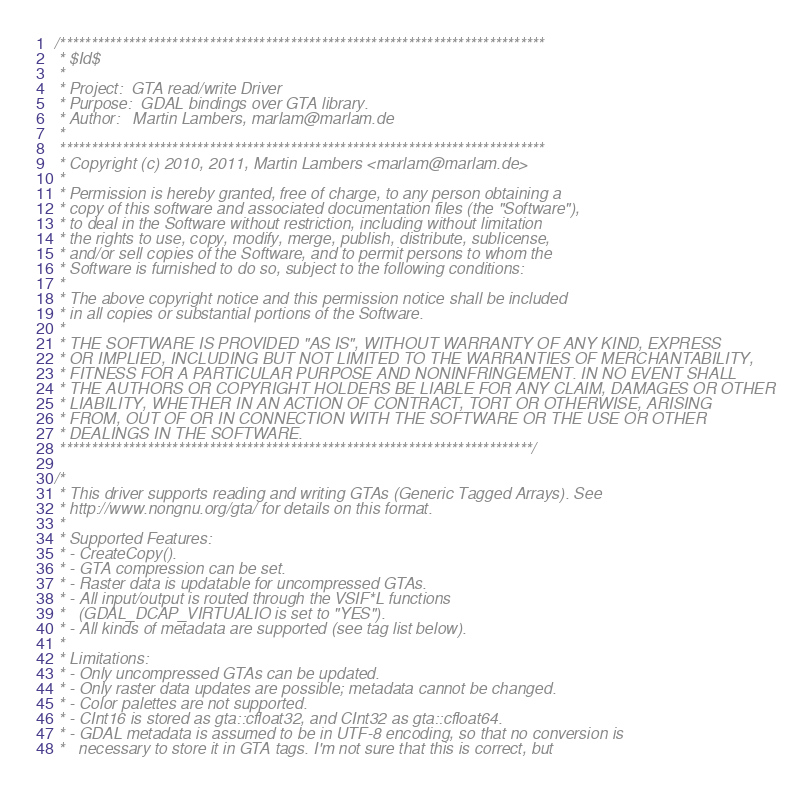<code> <loc_0><loc_0><loc_500><loc_500><_C++_>/******************************************************************************
 * $Id$
 *
 * Project:  GTA read/write Driver
 * Purpose:  GDAL bindings over GTA library.
 * Author:   Martin Lambers, marlam@marlam.de
 *
 ******************************************************************************
 * Copyright (c) 2010, 2011, Martin Lambers <marlam@marlam.de>
 *
 * Permission is hereby granted, free of charge, to any person obtaining a
 * copy of this software and associated documentation files (the "Software"),
 * to deal in the Software without restriction, including without limitation
 * the rights to use, copy, modify, merge, publish, distribute, sublicense,
 * and/or sell copies of the Software, and to permit persons to whom the
 * Software is furnished to do so, subject to the following conditions:
 *
 * The above copyright notice and this permission notice shall be included
 * in all copies or substantial portions of the Software.
 *
 * THE SOFTWARE IS PROVIDED "AS IS", WITHOUT WARRANTY OF ANY KIND, EXPRESS
 * OR IMPLIED, INCLUDING BUT NOT LIMITED TO THE WARRANTIES OF MERCHANTABILITY,
 * FITNESS FOR A PARTICULAR PURPOSE AND NONINFRINGEMENT. IN NO EVENT SHALL
 * THE AUTHORS OR COPYRIGHT HOLDERS BE LIABLE FOR ANY CLAIM, DAMAGES OR OTHER
 * LIABILITY, WHETHER IN AN ACTION OF CONTRACT, TORT OR OTHERWISE, ARISING
 * FROM, OUT OF OR IN CONNECTION WITH THE SOFTWARE OR THE USE OR OTHER
 * DEALINGS IN THE SOFTWARE.
 ****************************************************************************/

/*
 * This driver supports reading and writing GTAs (Generic Tagged Arrays). See
 * http://www.nongnu.org/gta/ for details on this format.
 *
 * Supported Features:
 * - CreateCopy().
 * - GTA compression can be set.
 * - Raster data is updatable for uncompressed GTAs.
 * - All input/output is routed through the VSIF*L functions
 *   (GDAL_DCAP_VIRTUALIO is set to "YES").
 * - All kinds of metadata are supported (see tag list below).
 *
 * Limitations:
 * - Only uncompressed GTAs can be updated.
 * - Only raster data updates are possible; metadata cannot be changed.
 * - Color palettes are not supported.
 * - CInt16 is stored as gta::cfloat32, and CInt32 as gta::cfloat64.
 * - GDAL metadata is assumed to be in UTF-8 encoding, so that no conversion is
 *   necessary to store it in GTA tags. I'm not sure that this is correct, but</code> 